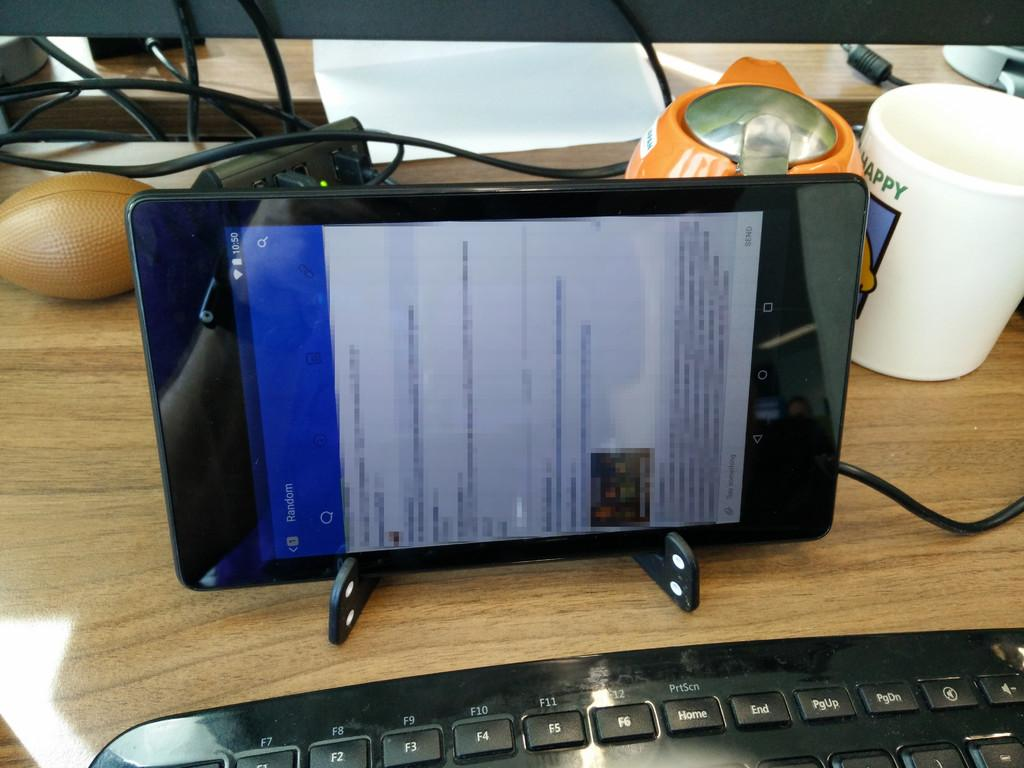What is the main object in the image? There is a gadget in the image. What feature does the gadget have? The gadget has a screen. What type of object can be seen on the table in the image? There is a white color cup on the table in the image. What is connected to the gadget in the image? There is a wire in the image. What is used for input in the image? There is a keyboard in the image. What type of notebook is lying on the floor in the image? There is no notebook present in the image. What type of land is visible in the image? The image does not depict any land; it is focused on the gadget and related objects. 